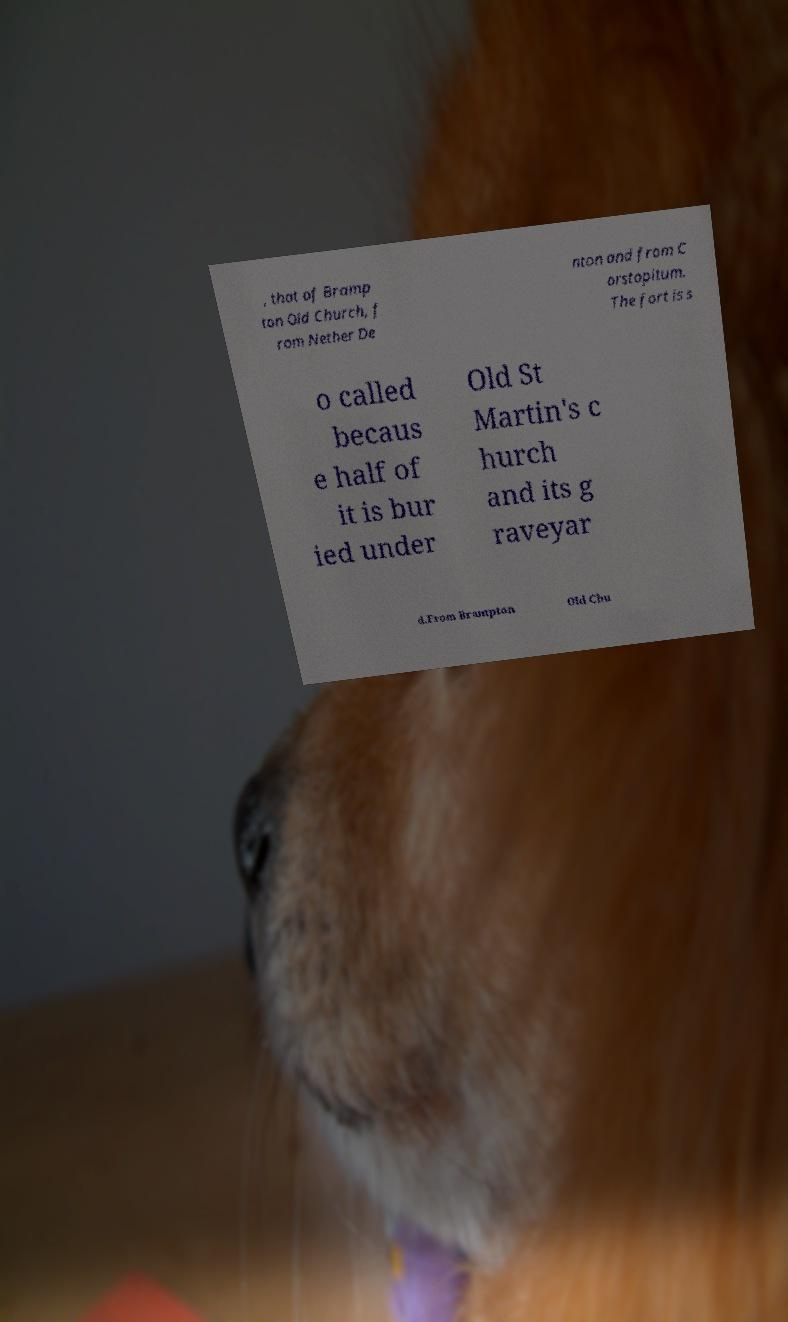Please read and relay the text visible in this image. What does it say? , that of Bramp ton Old Church, f rom Nether De nton and from C orstopitum. The fort is s o called becaus e half of it is bur ied under Old St Martin's c hurch and its g raveyar d.From Brampton Old Chu 